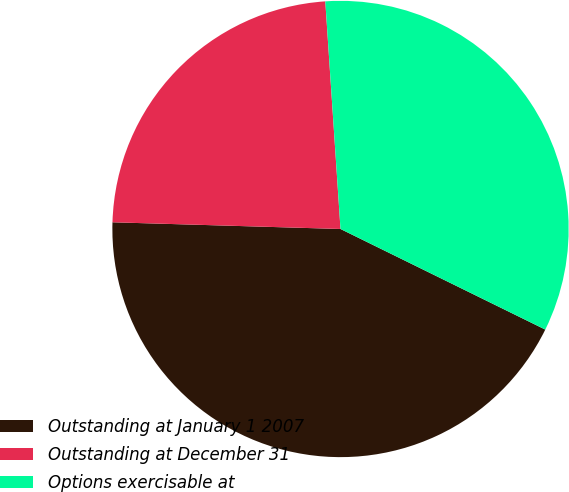Convert chart. <chart><loc_0><loc_0><loc_500><loc_500><pie_chart><fcel>Outstanding at January 1 2007<fcel>Outstanding at December 31<fcel>Options exercisable at<nl><fcel>43.2%<fcel>23.47%<fcel>33.33%<nl></chart> 